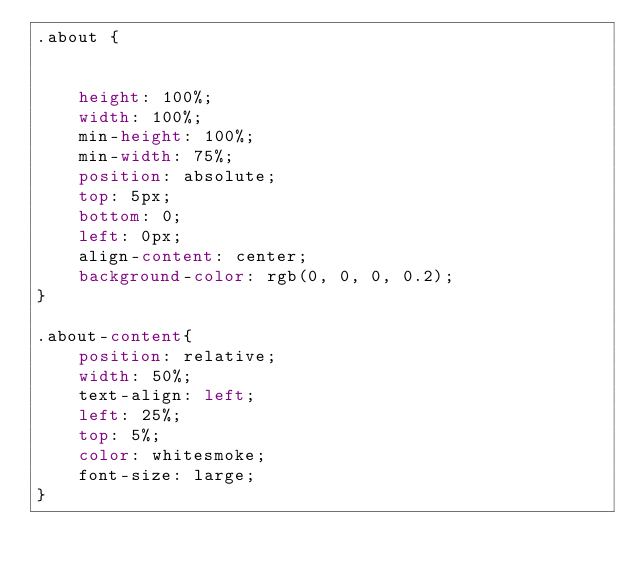Convert code to text. <code><loc_0><loc_0><loc_500><loc_500><_CSS_>.about {
    

    height: 100%;
    width: 100%;
    min-height: 100%;
    min-width: 75%;
    position: absolute;
    top: 5px;
    bottom: 0;
    left: 0px;
    align-content: center;
    background-color: rgb(0, 0, 0, 0.2);
}

.about-content{
    position: relative;
    width: 50%;
    text-align: left;
    left: 25%;
    top: 5%;
    color: whitesmoke;
    font-size: large;
}</code> 